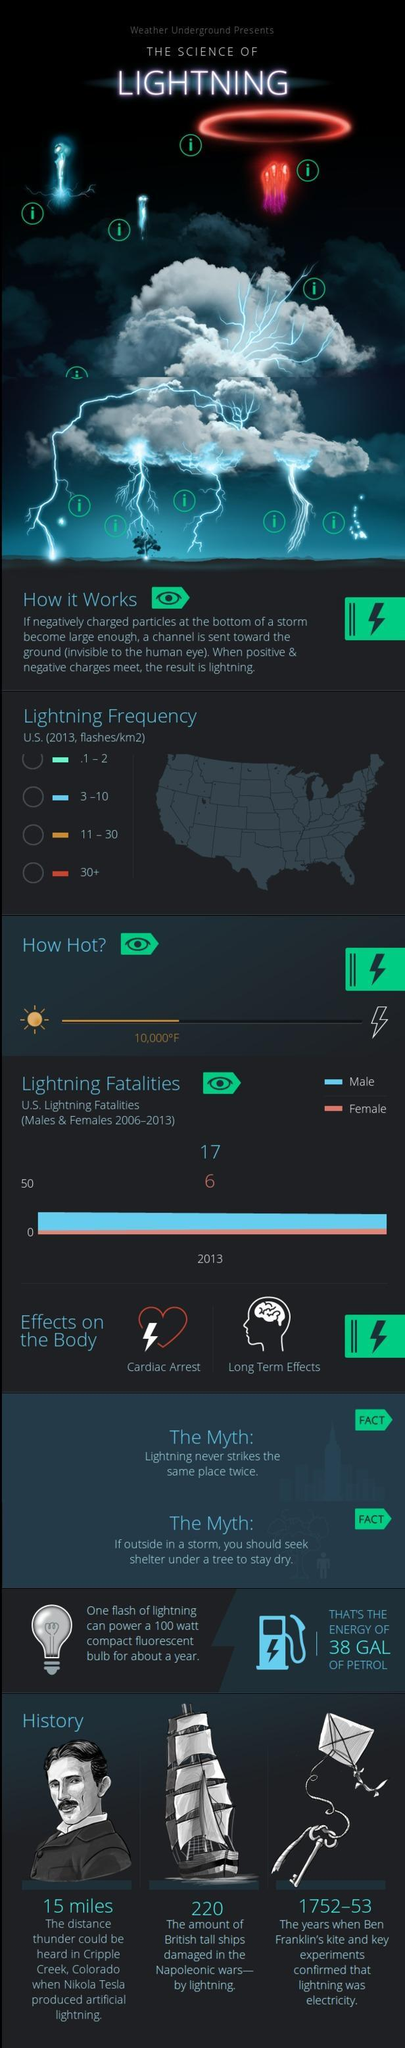How many more men have died due to lightning than women during 2006-2013?
Answer the question with a short phrase. 11 